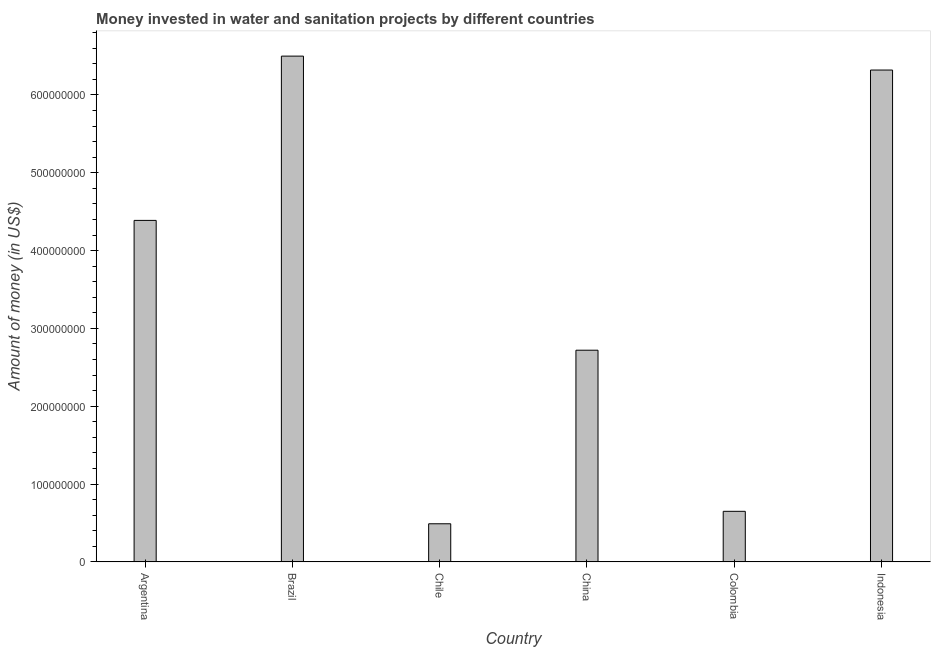Does the graph contain any zero values?
Give a very brief answer. No. Does the graph contain grids?
Keep it short and to the point. No. What is the title of the graph?
Your answer should be compact. Money invested in water and sanitation projects by different countries. What is the label or title of the X-axis?
Offer a very short reply. Country. What is the label or title of the Y-axis?
Your answer should be very brief. Amount of money (in US$). What is the investment in Colombia?
Offer a terse response. 6.50e+07. Across all countries, what is the maximum investment?
Offer a very short reply. 6.50e+08. Across all countries, what is the minimum investment?
Provide a short and direct response. 4.90e+07. In which country was the investment maximum?
Ensure brevity in your answer.  Brazil. What is the sum of the investment?
Keep it short and to the point. 2.11e+09. What is the difference between the investment in Brazil and China?
Provide a succinct answer. 3.78e+08. What is the average investment per country?
Your response must be concise. 3.51e+08. What is the median investment?
Keep it short and to the point. 3.55e+08. In how many countries, is the investment greater than 440000000 US$?
Provide a short and direct response. 2. What is the ratio of the investment in Argentina to that in Brazil?
Give a very brief answer. 0.68. What is the difference between the highest and the second highest investment?
Make the answer very short. 1.79e+07. Is the sum of the investment in China and Colombia greater than the maximum investment across all countries?
Your answer should be very brief. No. What is the difference between the highest and the lowest investment?
Your response must be concise. 6.01e+08. How many bars are there?
Provide a short and direct response. 6. Are all the bars in the graph horizontal?
Ensure brevity in your answer.  No. Are the values on the major ticks of Y-axis written in scientific E-notation?
Your answer should be very brief. No. What is the Amount of money (in US$) of Argentina?
Your answer should be compact. 4.39e+08. What is the Amount of money (in US$) in Brazil?
Your response must be concise. 6.50e+08. What is the Amount of money (in US$) of Chile?
Offer a terse response. 4.90e+07. What is the Amount of money (in US$) in China?
Your answer should be very brief. 2.72e+08. What is the Amount of money (in US$) of Colombia?
Your answer should be compact. 6.50e+07. What is the Amount of money (in US$) of Indonesia?
Your answer should be compact. 6.32e+08. What is the difference between the Amount of money (in US$) in Argentina and Brazil?
Your response must be concise. -2.11e+08. What is the difference between the Amount of money (in US$) in Argentina and Chile?
Offer a very short reply. 3.90e+08. What is the difference between the Amount of money (in US$) in Argentina and China?
Make the answer very short. 1.67e+08. What is the difference between the Amount of money (in US$) in Argentina and Colombia?
Ensure brevity in your answer.  3.74e+08. What is the difference between the Amount of money (in US$) in Argentina and Indonesia?
Make the answer very short. -1.93e+08. What is the difference between the Amount of money (in US$) in Brazil and Chile?
Keep it short and to the point. 6.01e+08. What is the difference between the Amount of money (in US$) in Brazil and China?
Give a very brief answer. 3.78e+08. What is the difference between the Amount of money (in US$) in Brazil and Colombia?
Provide a succinct answer. 5.85e+08. What is the difference between the Amount of money (in US$) in Brazil and Indonesia?
Provide a short and direct response. 1.79e+07. What is the difference between the Amount of money (in US$) in Chile and China?
Offer a very short reply. -2.23e+08. What is the difference between the Amount of money (in US$) in Chile and Colombia?
Keep it short and to the point. -1.60e+07. What is the difference between the Amount of money (in US$) in Chile and Indonesia?
Ensure brevity in your answer.  -5.83e+08. What is the difference between the Amount of money (in US$) in China and Colombia?
Offer a very short reply. 2.07e+08. What is the difference between the Amount of money (in US$) in China and Indonesia?
Provide a succinct answer. -3.60e+08. What is the difference between the Amount of money (in US$) in Colombia and Indonesia?
Your response must be concise. -5.67e+08. What is the ratio of the Amount of money (in US$) in Argentina to that in Brazil?
Offer a terse response. 0.68. What is the ratio of the Amount of money (in US$) in Argentina to that in Chile?
Provide a short and direct response. 8.96. What is the ratio of the Amount of money (in US$) in Argentina to that in China?
Make the answer very short. 1.61. What is the ratio of the Amount of money (in US$) in Argentina to that in Colombia?
Provide a succinct answer. 6.75. What is the ratio of the Amount of money (in US$) in Argentina to that in Indonesia?
Keep it short and to the point. 0.69. What is the ratio of the Amount of money (in US$) in Brazil to that in Chile?
Offer a very short reply. 13.26. What is the ratio of the Amount of money (in US$) in Brazil to that in China?
Offer a terse response. 2.39. What is the ratio of the Amount of money (in US$) in Brazil to that in Colombia?
Make the answer very short. 10. What is the ratio of the Amount of money (in US$) in Brazil to that in Indonesia?
Provide a short and direct response. 1.03. What is the ratio of the Amount of money (in US$) in Chile to that in China?
Make the answer very short. 0.18. What is the ratio of the Amount of money (in US$) in Chile to that in Colombia?
Your response must be concise. 0.75. What is the ratio of the Amount of money (in US$) in Chile to that in Indonesia?
Keep it short and to the point. 0.08. What is the ratio of the Amount of money (in US$) in China to that in Colombia?
Keep it short and to the point. 4.18. What is the ratio of the Amount of money (in US$) in China to that in Indonesia?
Offer a very short reply. 0.43. What is the ratio of the Amount of money (in US$) in Colombia to that in Indonesia?
Keep it short and to the point. 0.1. 